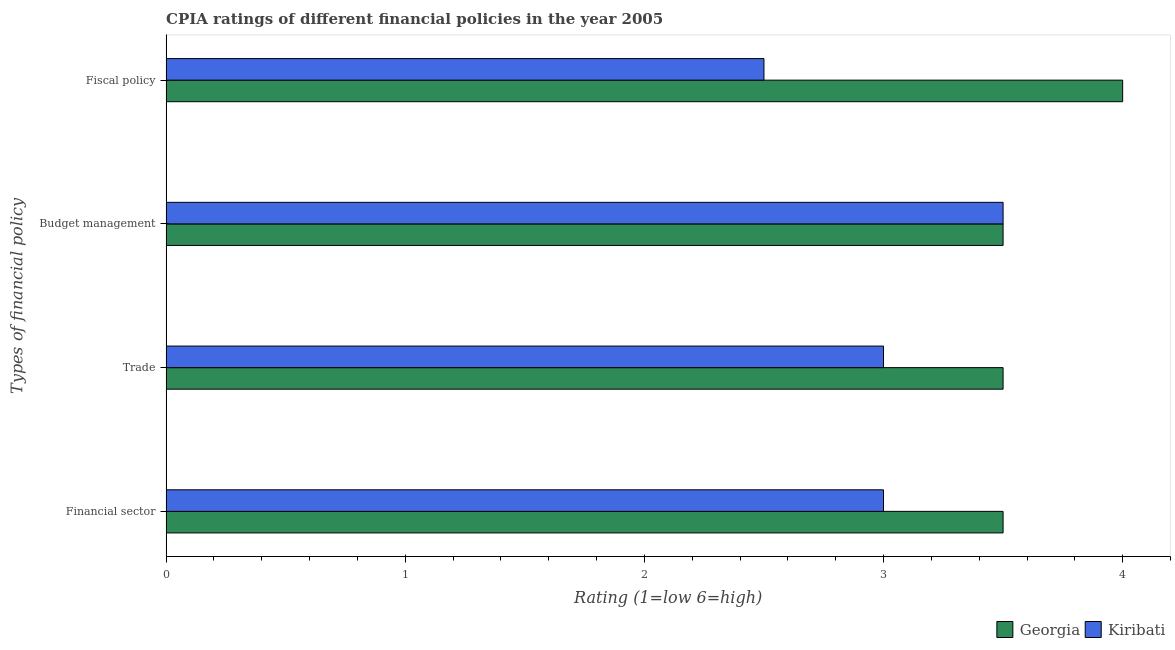How many different coloured bars are there?
Offer a terse response. 2. How many groups of bars are there?
Provide a succinct answer. 4. Are the number of bars on each tick of the Y-axis equal?
Ensure brevity in your answer.  Yes. How many bars are there on the 2nd tick from the top?
Ensure brevity in your answer.  2. How many bars are there on the 2nd tick from the bottom?
Your response must be concise. 2. What is the label of the 3rd group of bars from the top?
Offer a very short reply. Trade. Across all countries, what is the minimum cpia rating of budget management?
Provide a succinct answer. 3.5. In which country was the cpia rating of budget management maximum?
Your response must be concise. Georgia. In which country was the cpia rating of budget management minimum?
Provide a short and direct response. Georgia. What is the difference between the cpia rating of fiscal policy in Georgia and that in Kiribati?
Offer a terse response. 1.5. What is the difference between the cpia rating of fiscal policy in Kiribati and the cpia rating of budget management in Georgia?
Your response must be concise. -1. What is the average cpia rating of trade per country?
Your answer should be compact. 3.25. What is the difference between the cpia rating of budget management and cpia rating of financial sector in Georgia?
Make the answer very short. 0. What is the ratio of the cpia rating of budget management in Kiribati to that in Georgia?
Your answer should be compact. 1. Is the cpia rating of fiscal policy in Kiribati less than that in Georgia?
Offer a terse response. Yes. What is the difference between the highest and the second highest cpia rating of fiscal policy?
Your response must be concise. 1.5. Is it the case that in every country, the sum of the cpia rating of financial sector and cpia rating of budget management is greater than the sum of cpia rating of fiscal policy and cpia rating of trade?
Provide a short and direct response. No. What does the 1st bar from the top in Fiscal policy represents?
Your answer should be compact. Kiribati. What does the 2nd bar from the bottom in Financial sector represents?
Give a very brief answer. Kiribati. How many bars are there?
Keep it short and to the point. 8. Are all the bars in the graph horizontal?
Ensure brevity in your answer.  Yes. Does the graph contain any zero values?
Make the answer very short. No. Does the graph contain grids?
Your answer should be very brief. No. How are the legend labels stacked?
Ensure brevity in your answer.  Horizontal. What is the title of the graph?
Offer a very short reply. CPIA ratings of different financial policies in the year 2005. Does "Malta" appear as one of the legend labels in the graph?
Provide a succinct answer. No. What is the label or title of the Y-axis?
Your answer should be compact. Types of financial policy. What is the Rating (1=low 6=high) of Georgia in Budget management?
Keep it short and to the point. 3.5. What is the Rating (1=low 6=high) in Kiribati in Budget management?
Ensure brevity in your answer.  3.5. What is the Rating (1=low 6=high) of Georgia in Fiscal policy?
Offer a very short reply. 4. What is the Rating (1=low 6=high) in Kiribati in Fiscal policy?
Your answer should be very brief. 2.5. Across all Types of financial policy, what is the maximum Rating (1=low 6=high) of Georgia?
Ensure brevity in your answer.  4. Across all Types of financial policy, what is the minimum Rating (1=low 6=high) in Georgia?
Ensure brevity in your answer.  3.5. What is the total Rating (1=low 6=high) of Georgia in the graph?
Provide a short and direct response. 14.5. What is the difference between the Rating (1=low 6=high) of Kiribati in Financial sector and that in Budget management?
Make the answer very short. -0.5. What is the difference between the Rating (1=low 6=high) of Kiribati in Trade and that in Budget management?
Provide a short and direct response. -0.5. What is the difference between the Rating (1=low 6=high) in Georgia in Trade and that in Fiscal policy?
Offer a very short reply. -0.5. What is the difference between the Rating (1=low 6=high) in Kiribati in Trade and that in Fiscal policy?
Offer a very short reply. 0.5. What is the difference between the Rating (1=low 6=high) of Georgia in Budget management and that in Fiscal policy?
Offer a terse response. -0.5. What is the difference between the Rating (1=low 6=high) in Georgia in Financial sector and the Rating (1=low 6=high) in Kiribati in Trade?
Offer a very short reply. 0.5. What is the difference between the Rating (1=low 6=high) in Georgia in Financial sector and the Rating (1=low 6=high) in Kiribati in Budget management?
Ensure brevity in your answer.  0. What is the difference between the Rating (1=low 6=high) of Georgia in Budget management and the Rating (1=low 6=high) of Kiribati in Fiscal policy?
Keep it short and to the point. 1. What is the average Rating (1=low 6=high) of Georgia per Types of financial policy?
Give a very brief answer. 3.62. What is the difference between the Rating (1=low 6=high) in Georgia and Rating (1=low 6=high) in Kiribati in Financial sector?
Give a very brief answer. 0.5. What is the difference between the Rating (1=low 6=high) of Georgia and Rating (1=low 6=high) of Kiribati in Budget management?
Ensure brevity in your answer.  0. What is the difference between the Rating (1=low 6=high) in Georgia and Rating (1=low 6=high) in Kiribati in Fiscal policy?
Offer a very short reply. 1.5. What is the ratio of the Rating (1=low 6=high) in Georgia in Financial sector to that in Budget management?
Offer a very short reply. 1. What is the ratio of the Rating (1=low 6=high) of Kiribati in Financial sector to that in Fiscal policy?
Your answer should be very brief. 1.2. What is the ratio of the Rating (1=low 6=high) of Kiribati in Trade to that in Budget management?
Your response must be concise. 0.86. What is the ratio of the Rating (1=low 6=high) of Georgia in Trade to that in Fiscal policy?
Your answer should be compact. 0.88. What is the ratio of the Rating (1=low 6=high) in Kiribati in Trade to that in Fiscal policy?
Your response must be concise. 1.2. What is the ratio of the Rating (1=low 6=high) of Kiribati in Budget management to that in Fiscal policy?
Your answer should be very brief. 1.4. What is the difference between the highest and the second highest Rating (1=low 6=high) in Georgia?
Your response must be concise. 0.5. What is the difference between the highest and the lowest Rating (1=low 6=high) in Kiribati?
Make the answer very short. 1. 